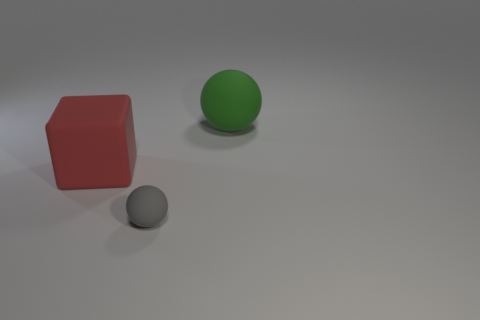Add 3 big red rubber cubes. How many objects exist? 6 Subtract all cubes. How many objects are left? 2 Subtract all objects. Subtract all red metal objects. How many objects are left? 0 Add 3 green spheres. How many green spheres are left? 4 Add 2 brown matte blocks. How many brown matte blocks exist? 2 Subtract 0 blue cylinders. How many objects are left? 3 